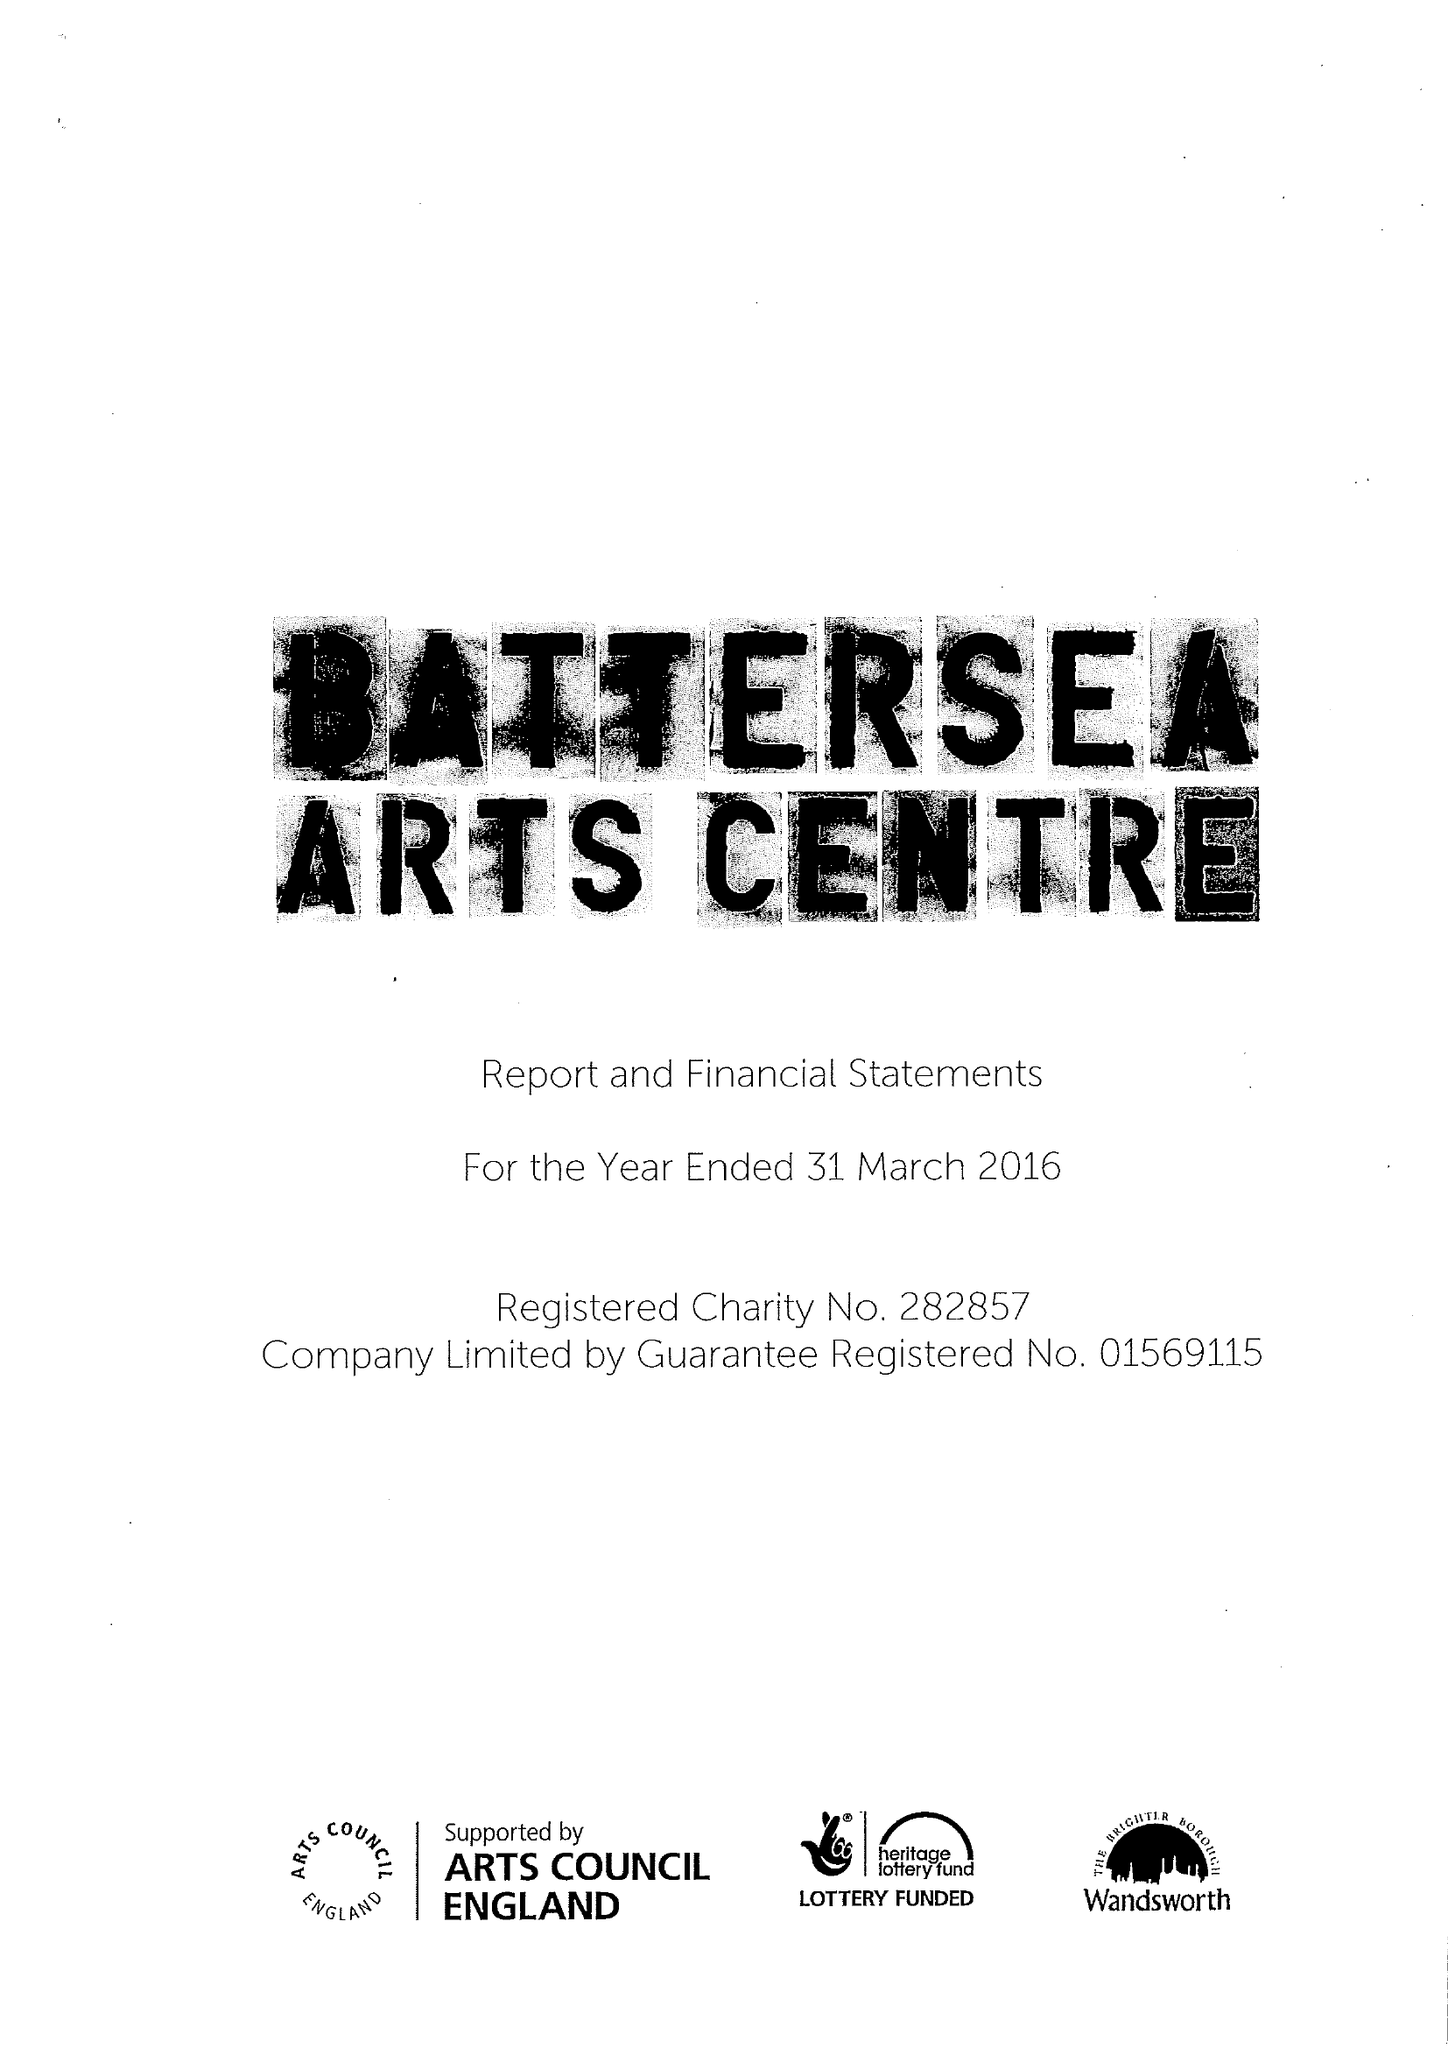What is the value for the report_date?
Answer the question using a single word or phrase. 2016-03-31 